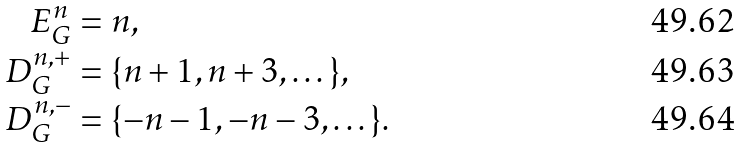<formula> <loc_0><loc_0><loc_500><loc_500>E _ { G } ^ { n } & = n , \\ D _ { G } ^ { n , + } & = \{ n + 1 , n + 3 , \dots \} , \\ D _ { G } ^ { n , - } & = \{ - n - 1 , - n - 3 , \dots \} .</formula> 